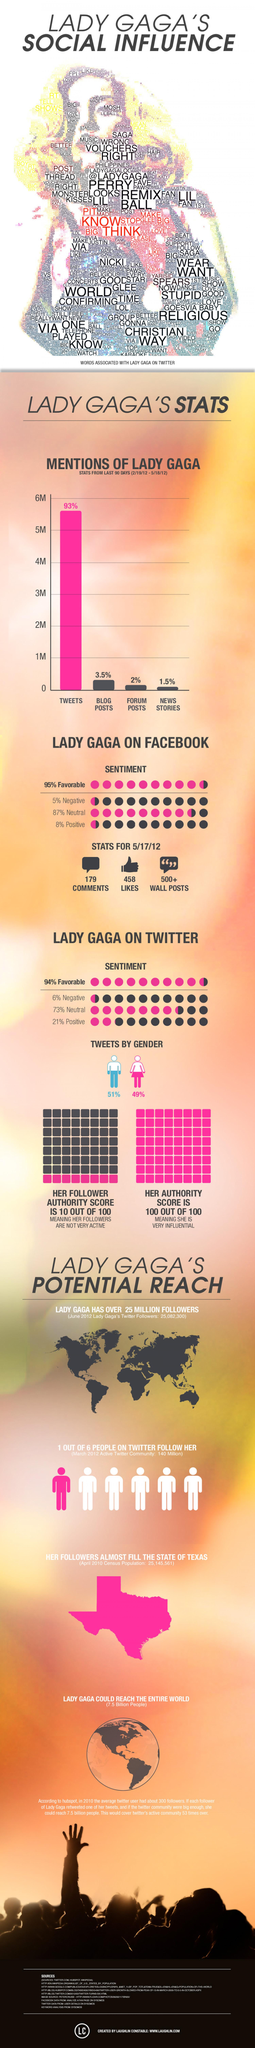List a handful of essential elements in this visual. The percentage of responses on Twitter about Lady Gaga that are not negative is 95%. According to the information available, it can be concluded that more talk about Lady Gaga occurs on Twitter than in news stories. The total percentage of responses on Twitter about Lady Gaga that are not neutral is 15%. 